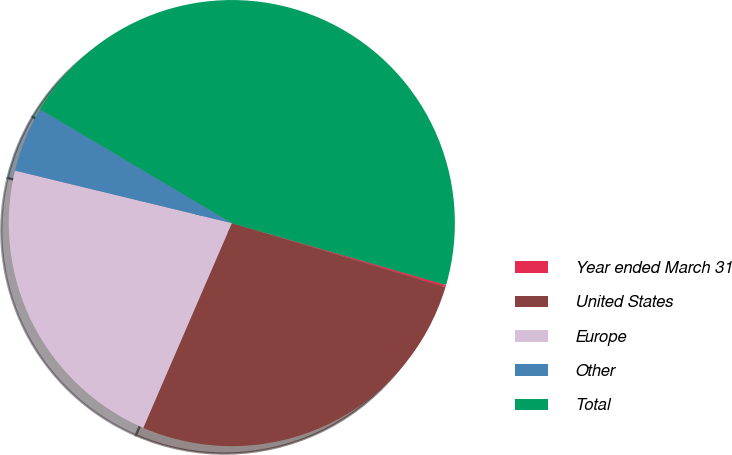Convert chart to OTSL. <chart><loc_0><loc_0><loc_500><loc_500><pie_chart><fcel>Year ended March 31<fcel>United States<fcel>Europe<fcel>Other<fcel>Total<nl><fcel>0.16%<fcel>26.86%<fcel>22.28%<fcel>4.74%<fcel>45.95%<nl></chart> 